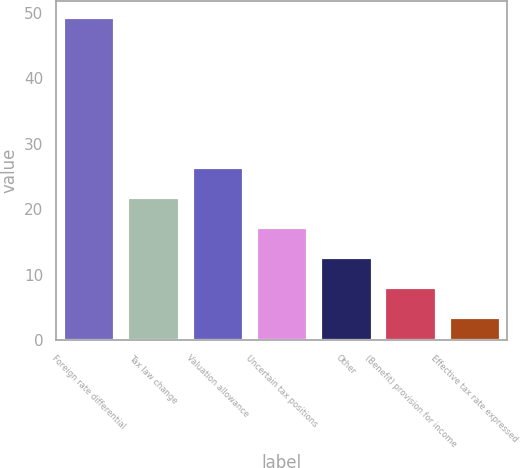Convert chart. <chart><loc_0><loc_0><loc_500><loc_500><bar_chart><fcel>Foreign rate differential<fcel>Tax law change<fcel>Valuation allowance<fcel>Uncertain tax positions<fcel>Other<fcel>(Benefit) provision for income<fcel>Effective tax rate expressed<nl><fcel>49.3<fcel>21.88<fcel>26.45<fcel>17.31<fcel>12.74<fcel>8.17<fcel>3.6<nl></chart> 